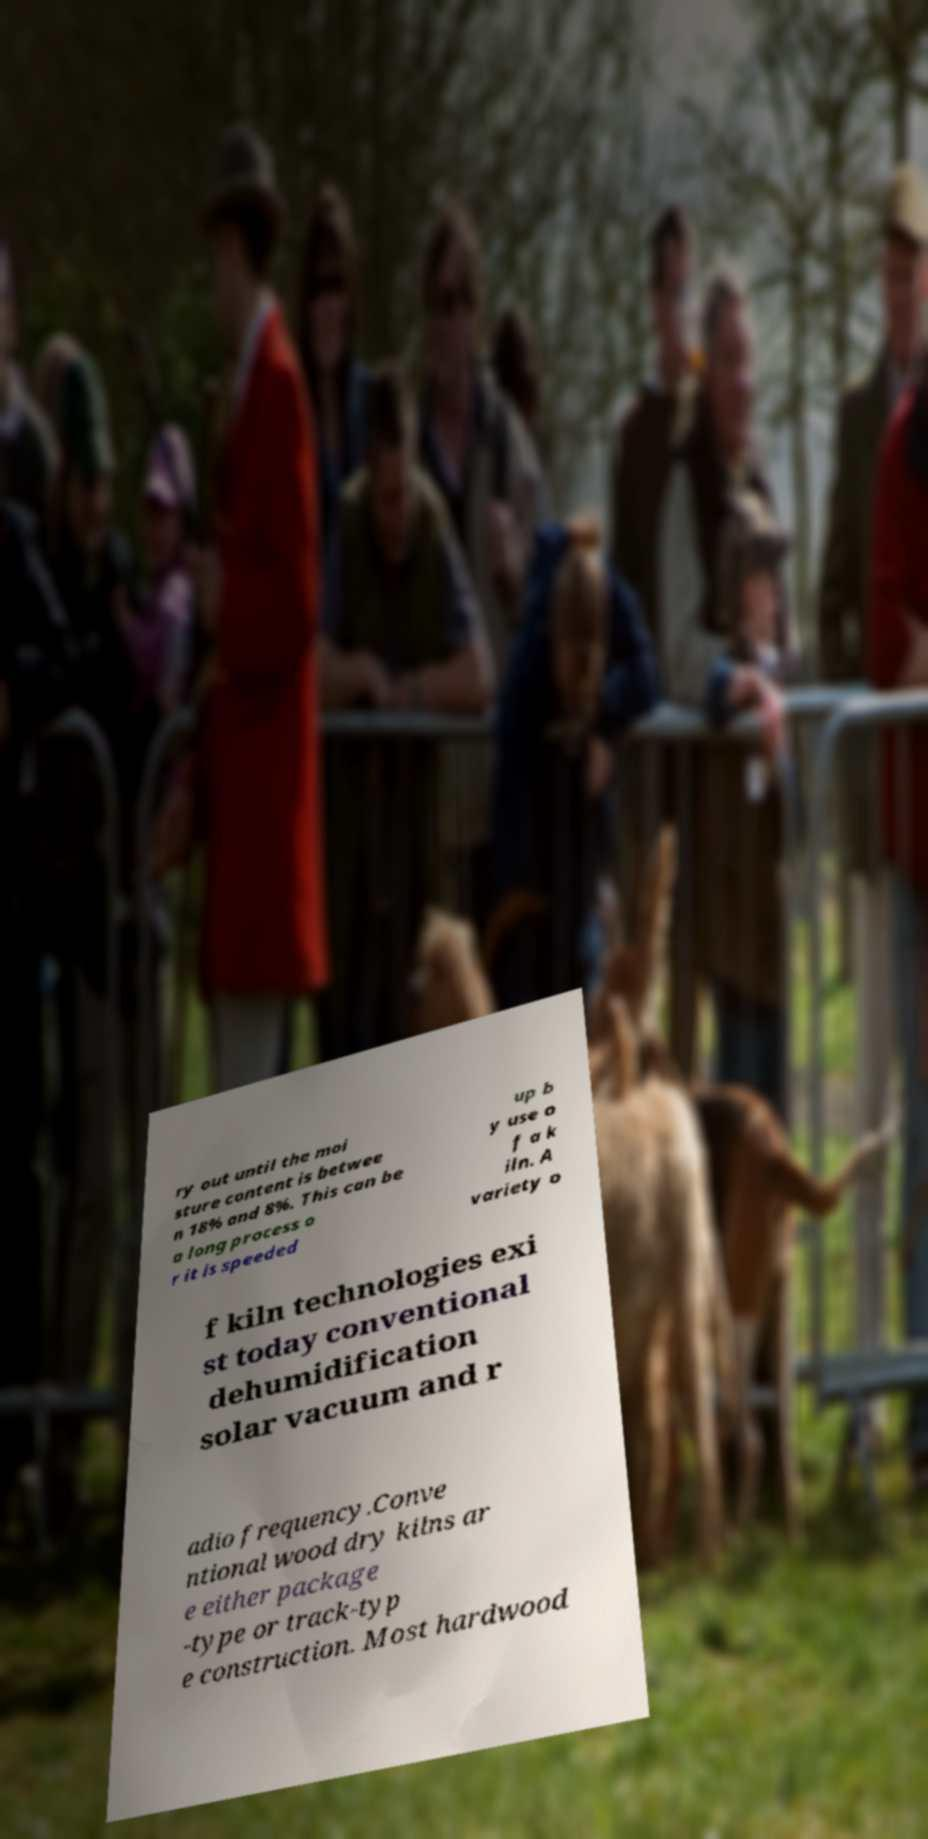For documentation purposes, I need the text within this image transcribed. Could you provide that? ry out until the moi sture content is betwee n 18% and 8%. This can be a long process o r it is speeded up b y use o f a k iln. A variety o f kiln technologies exi st today conventional dehumidification solar vacuum and r adio frequency.Conve ntional wood dry kilns ar e either package -type or track-typ e construction. Most hardwood 